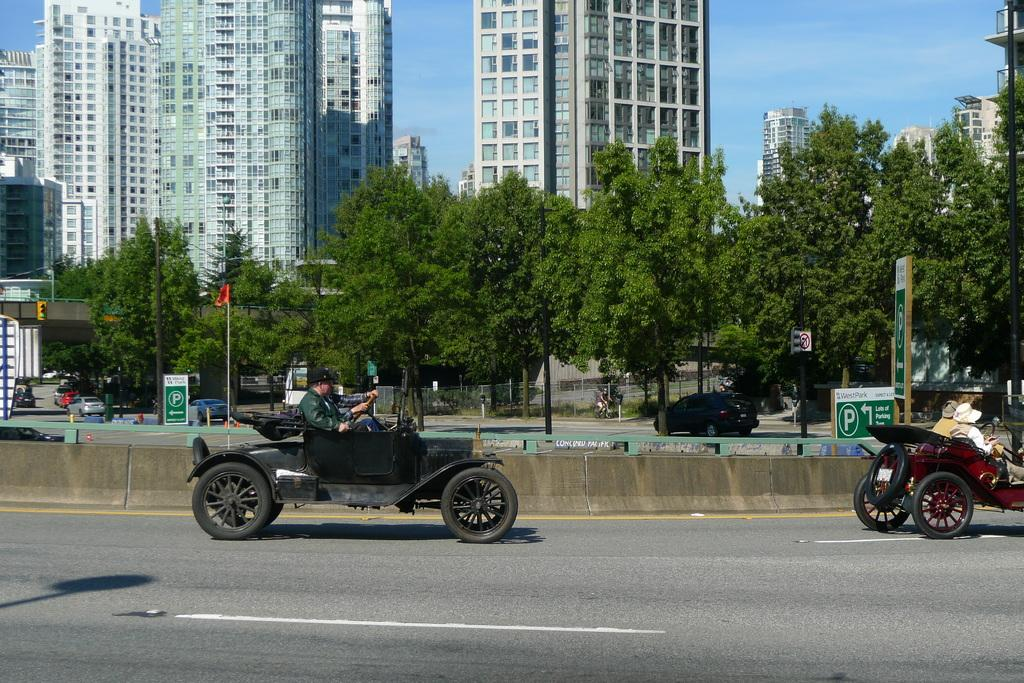What is happening on the road in the image? There are vehicles passing on the road in the image. What can be seen in the distance behind the road? There are buildings, trees, and poles in the background of the image. What might be used to indicate parking spaces in the image? The image includes parking boards. What type of development is taking place in the image? There is no specific development project mentioned or depicted in the image. How comfortable are the seats in the vehicles passing on the road? The image does not provide information about the comfort of the seats in the vehicles. 